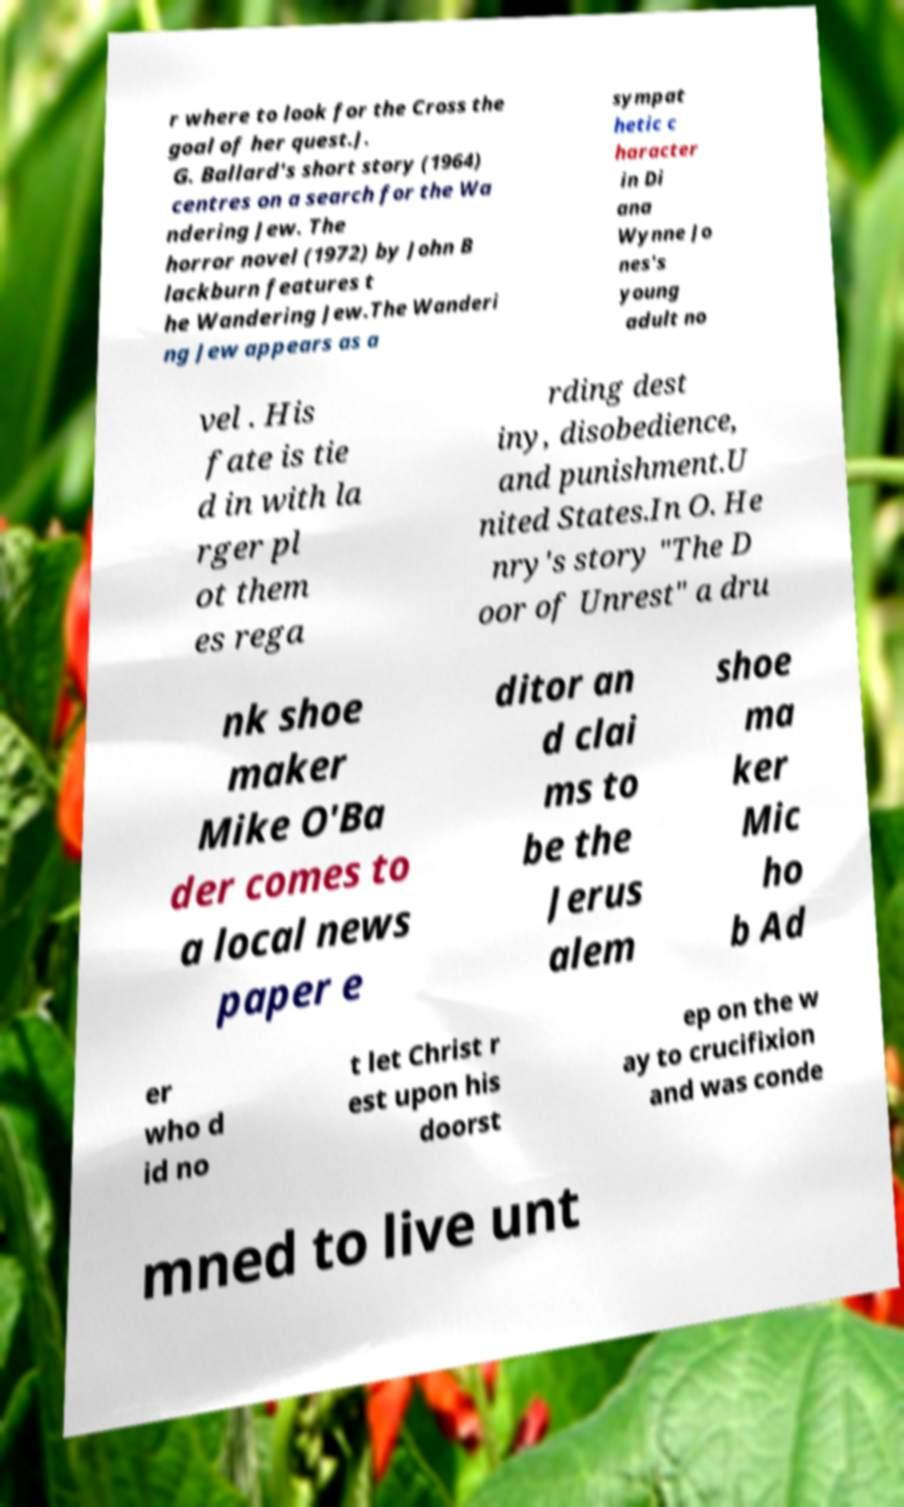Please read and relay the text visible in this image. What does it say? r where to look for the Cross the goal of her quest.J. G. Ballard's short story (1964) centres on a search for the Wa ndering Jew. The horror novel (1972) by John B lackburn features t he Wandering Jew.The Wanderi ng Jew appears as a sympat hetic c haracter in Di ana Wynne Jo nes's young adult no vel . His fate is tie d in with la rger pl ot them es rega rding dest iny, disobedience, and punishment.U nited States.In O. He nry's story "The D oor of Unrest" a dru nk shoe maker Mike O'Ba der comes to a local news paper e ditor an d clai ms to be the Jerus alem shoe ma ker Mic ho b Ad er who d id no t let Christ r est upon his doorst ep on the w ay to crucifixion and was conde mned to live unt 